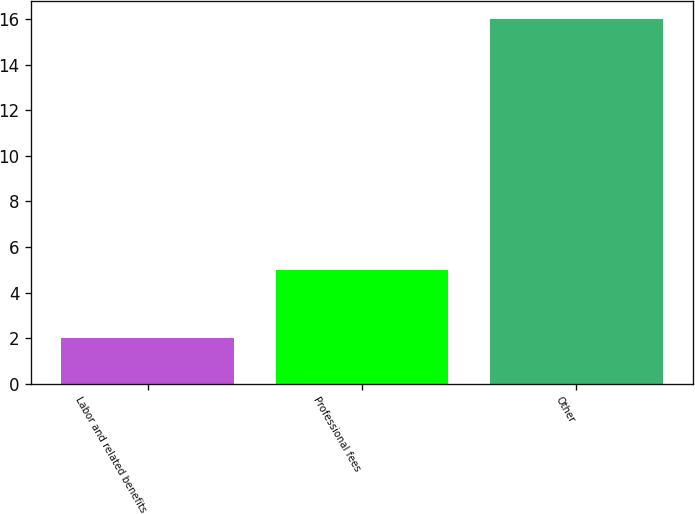Convert chart to OTSL. <chart><loc_0><loc_0><loc_500><loc_500><bar_chart><fcel>Labor and related benefits<fcel>Professional fees<fcel>Other<nl><fcel>2<fcel>5<fcel>16<nl></chart> 